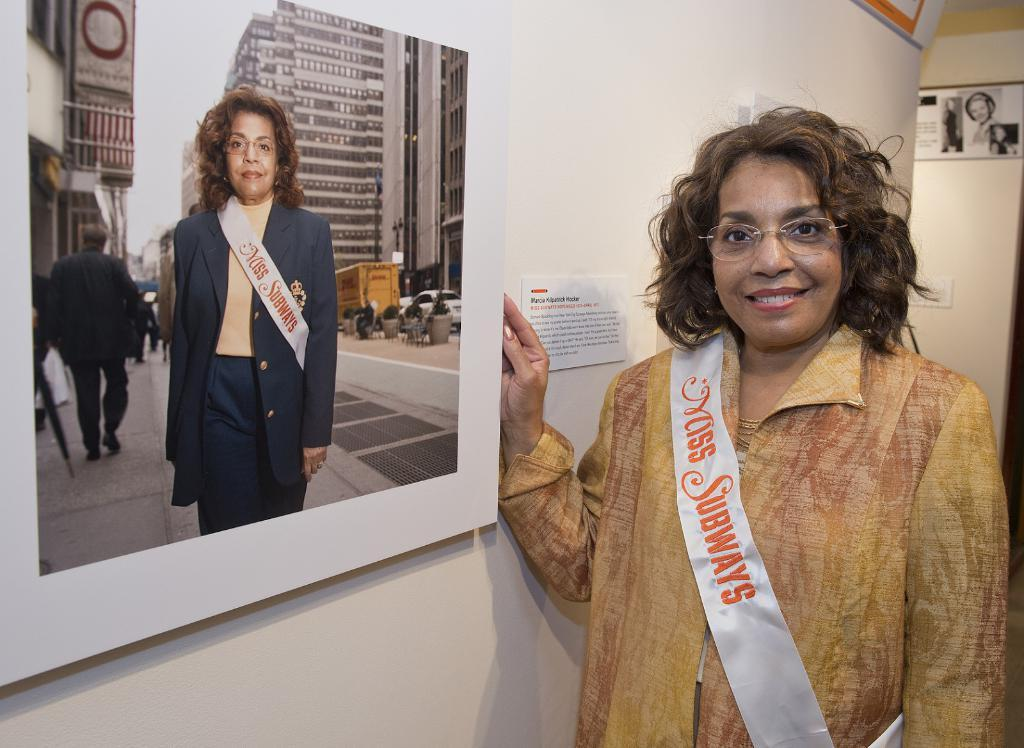Who is the main subject in the image? There is a lady in the image. What is the lady wearing on her face? The lady is wearing glasses. What else is the lady wearing? The lady is wearing a sash. What can be seen in the background of the image? There are posters and a photo frame on the wall in the background of the image. What type of nut is the lady holding in the image? There is no nut present in the image; the lady is not holding any object. 